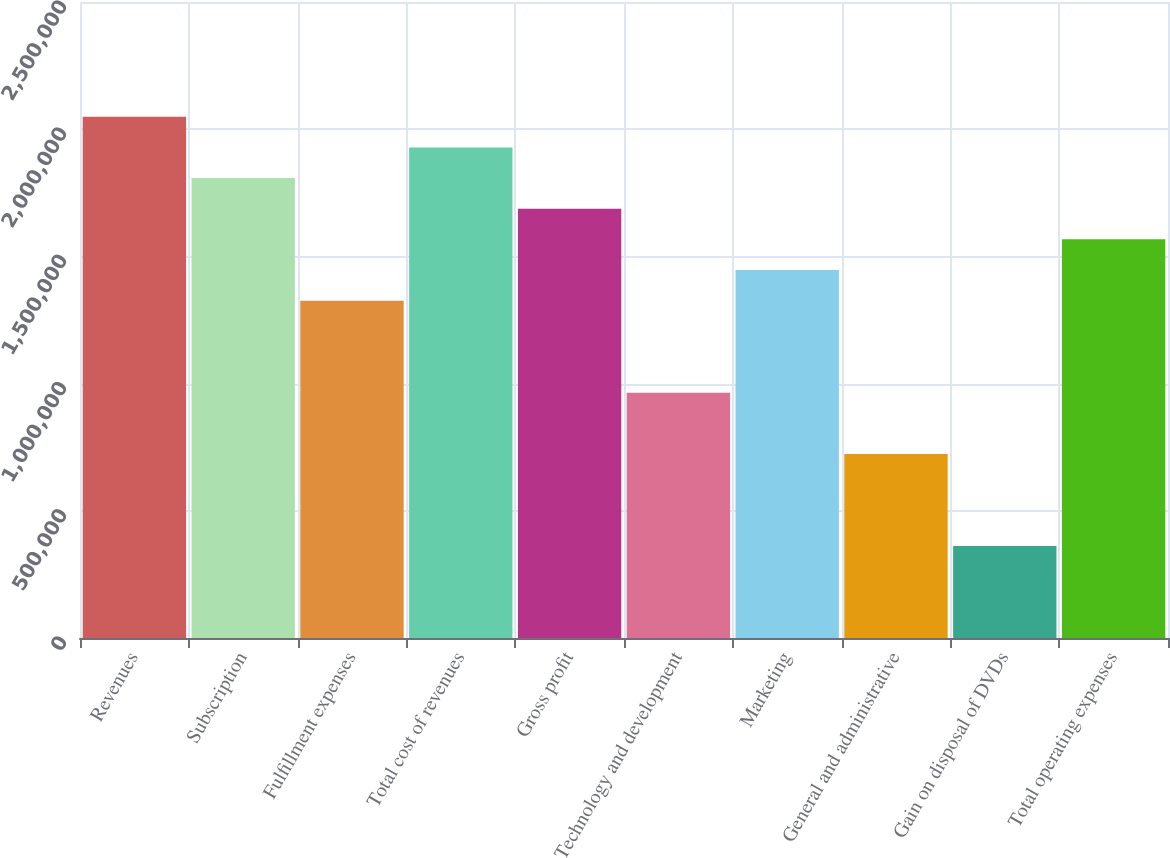<chart> <loc_0><loc_0><loc_500><loc_500><bar_chart><fcel>Revenues<fcel>Subscription<fcel>Fulfillment expenses<fcel>Total cost of revenues<fcel>Gross profit<fcel>Technology and development<fcel>Marketing<fcel>General and administrative<fcel>Gain on disposal of DVDs<fcel>Total operating expenses<nl><fcel>2.04908e+06<fcel>1.80801e+06<fcel>1.32587e+06<fcel>1.92854e+06<fcel>1.68748e+06<fcel>964272<fcel>1.44641e+06<fcel>723204<fcel>361603<fcel>1.56694e+06<nl></chart> 